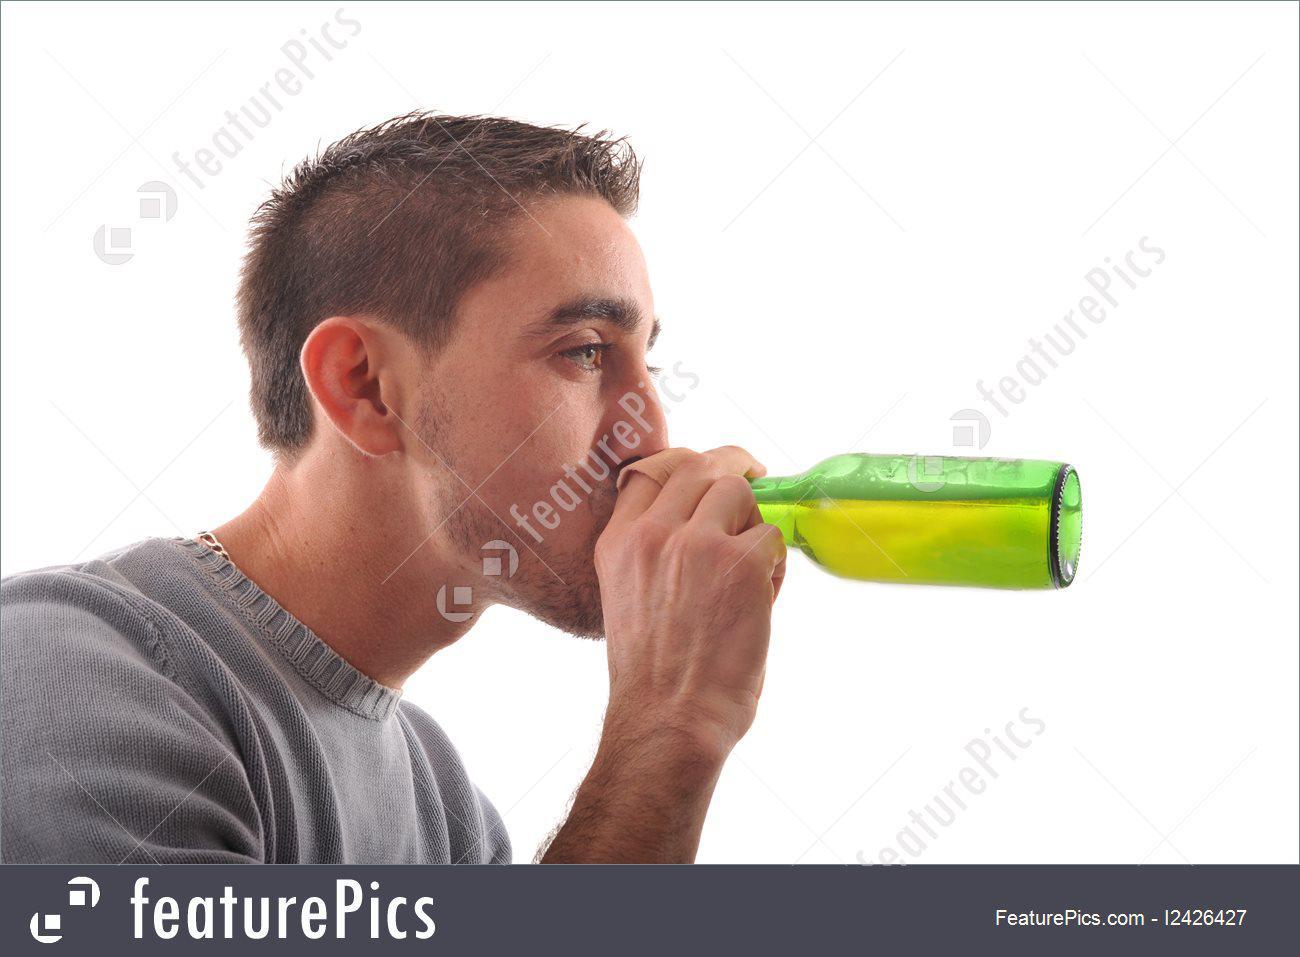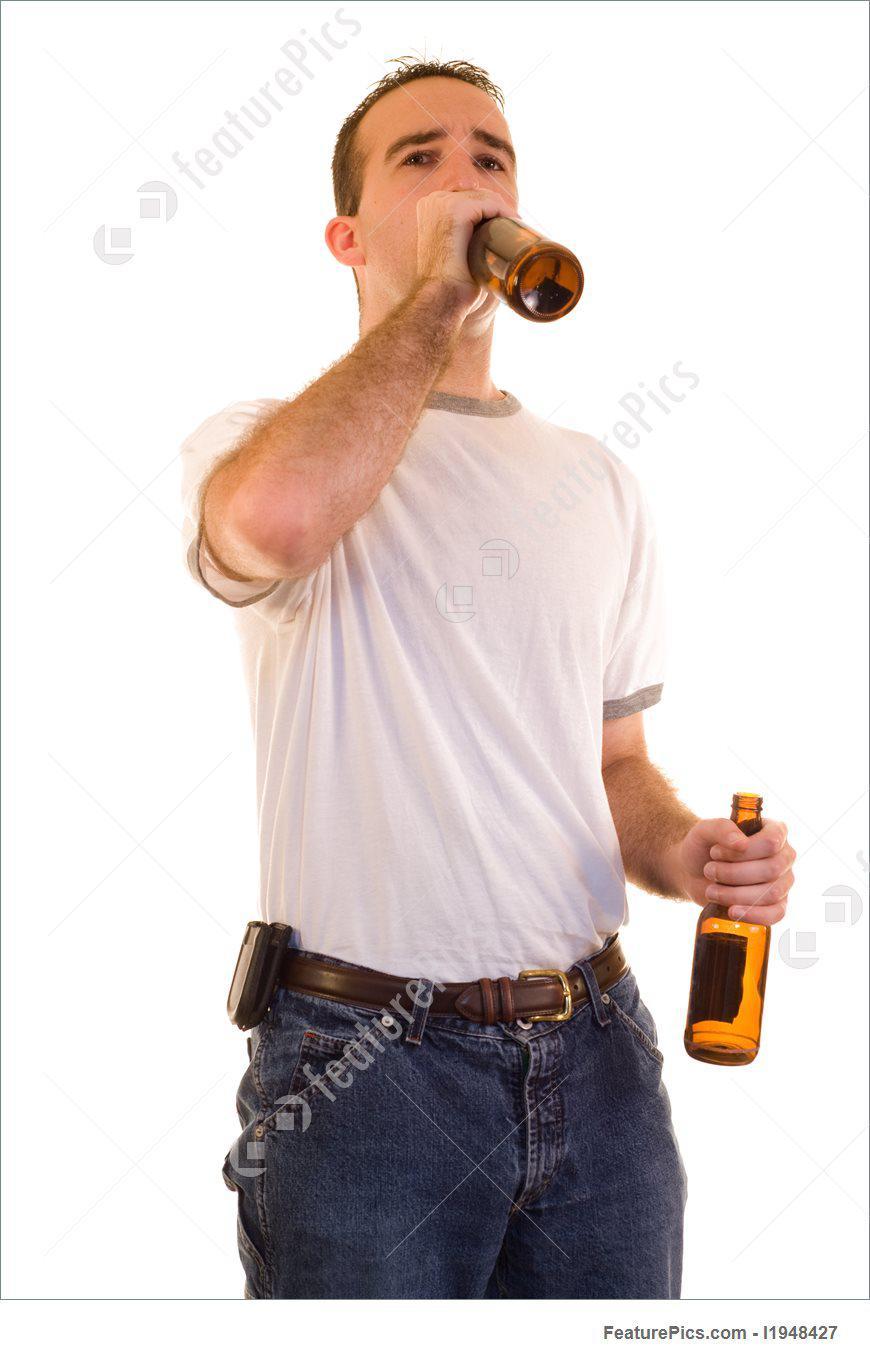The first image is the image on the left, the second image is the image on the right. Considering the images on both sides, is "The left and right image contains the same number of men standing drinking a single beer." valid? Answer yes or no. No. The first image is the image on the left, the second image is the image on the right. Given the left and right images, does the statement "One of these guys does not have a beer bottle at their lips." hold true? Answer yes or no. No. 